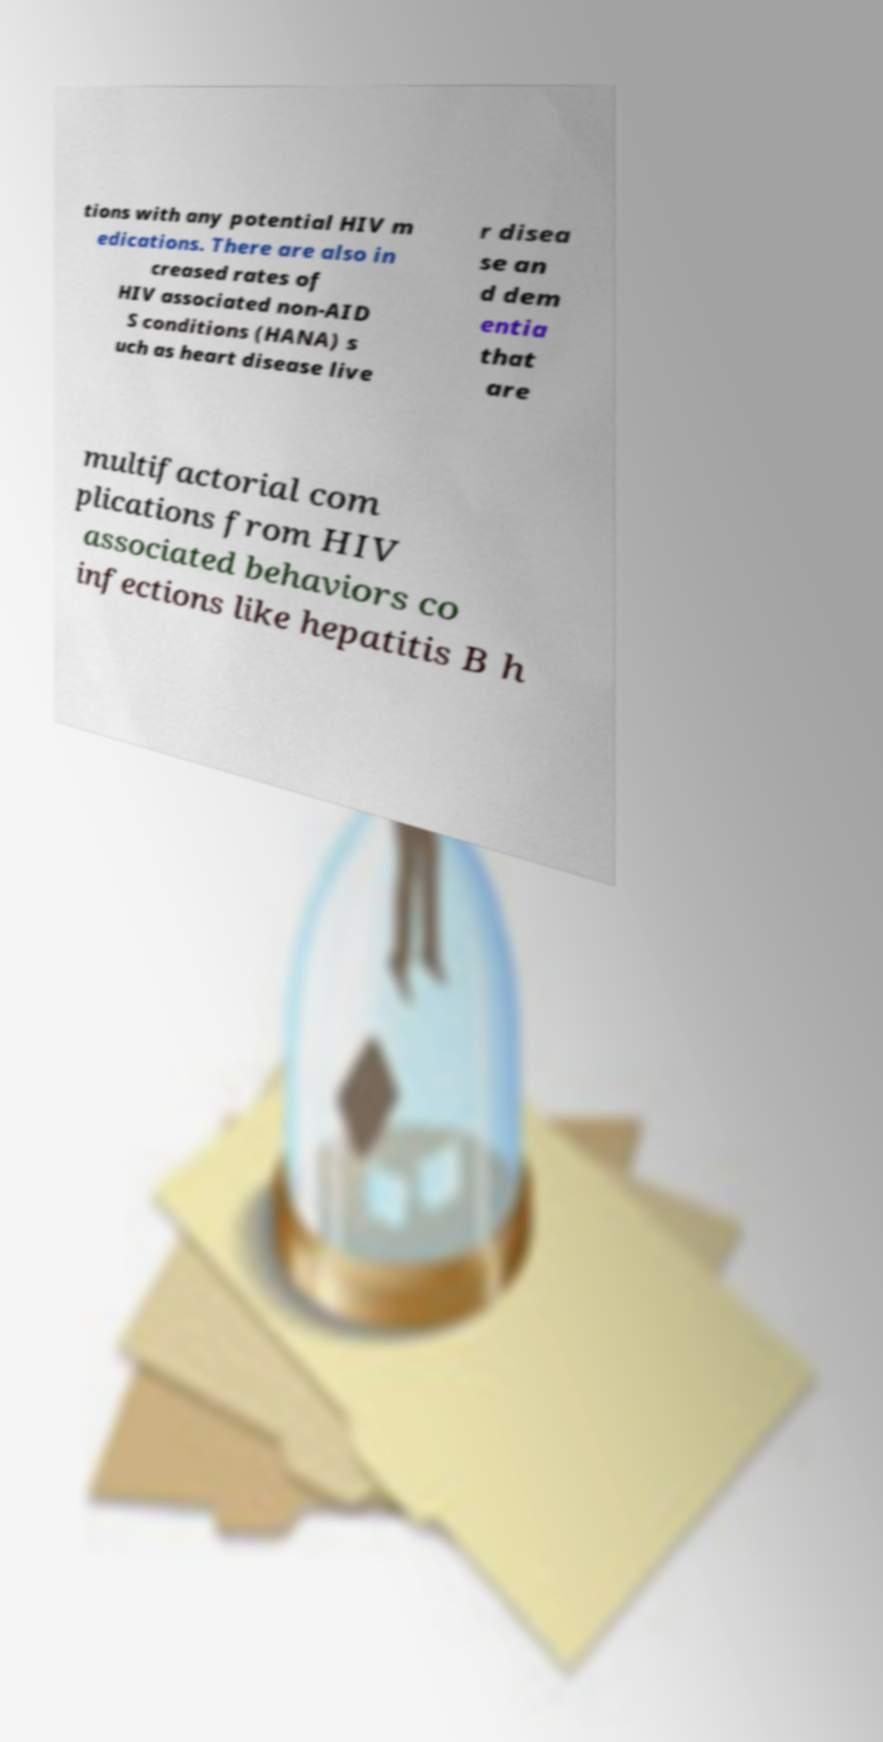Please identify and transcribe the text found in this image. tions with any potential HIV m edications. There are also in creased rates of HIV associated non-AID S conditions (HANA) s uch as heart disease live r disea se an d dem entia that are multifactorial com plications from HIV associated behaviors co infections like hepatitis B h 